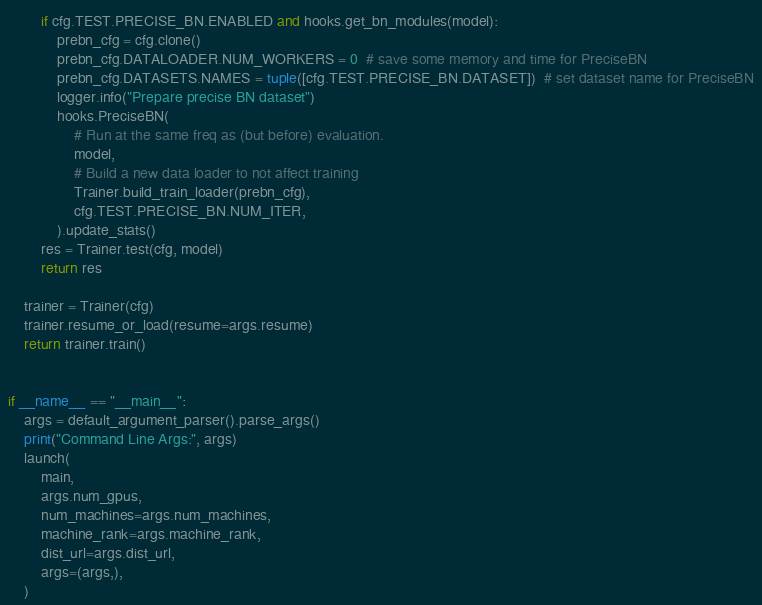Convert code to text. <code><loc_0><loc_0><loc_500><loc_500><_Python_>        if cfg.TEST.PRECISE_BN.ENABLED and hooks.get_bn_modules(model):
            prebn_cfg = cfg.clone()
            prebn_cfg.DATALOADER.NUM_WORKERS = 0  # save some memory and time for PreciseBN
            prebn_cfg.DATASETS.NAMES = tuple([cfg.TEST.PRECISE_BN.DATASET])  # set dataset name for PreciseBN
            logger.info("Prepare precise BN dataset")
            hooks.PreciseBN(
                # Run at the same freq as (but before) evaluation.
                model,
                # Build a new data loader to not affect training
                Trainer.build_train_loader(prebn_cfg),
                cfg.TEST.PRECISE_BN.NUM_ITER,
            ).update_stats()
        res = Trainer.test(cfg, model)
        return res

    trainer = Trainer(cfg)
    trainer.resume_or_load(resume=args.resume)
    return trainer.train()


if __name__ == "__main__":
    args = default_argument_parser().parse_args()
    print("Command Line Args:", args)
    launch(
        main,
        args.num_gpus,
        num_machines=args.num_machines,
        machine_rank=args.machine_rank,
        dist_url=args.dist_url,
        args=(args,),
    )
</code> 